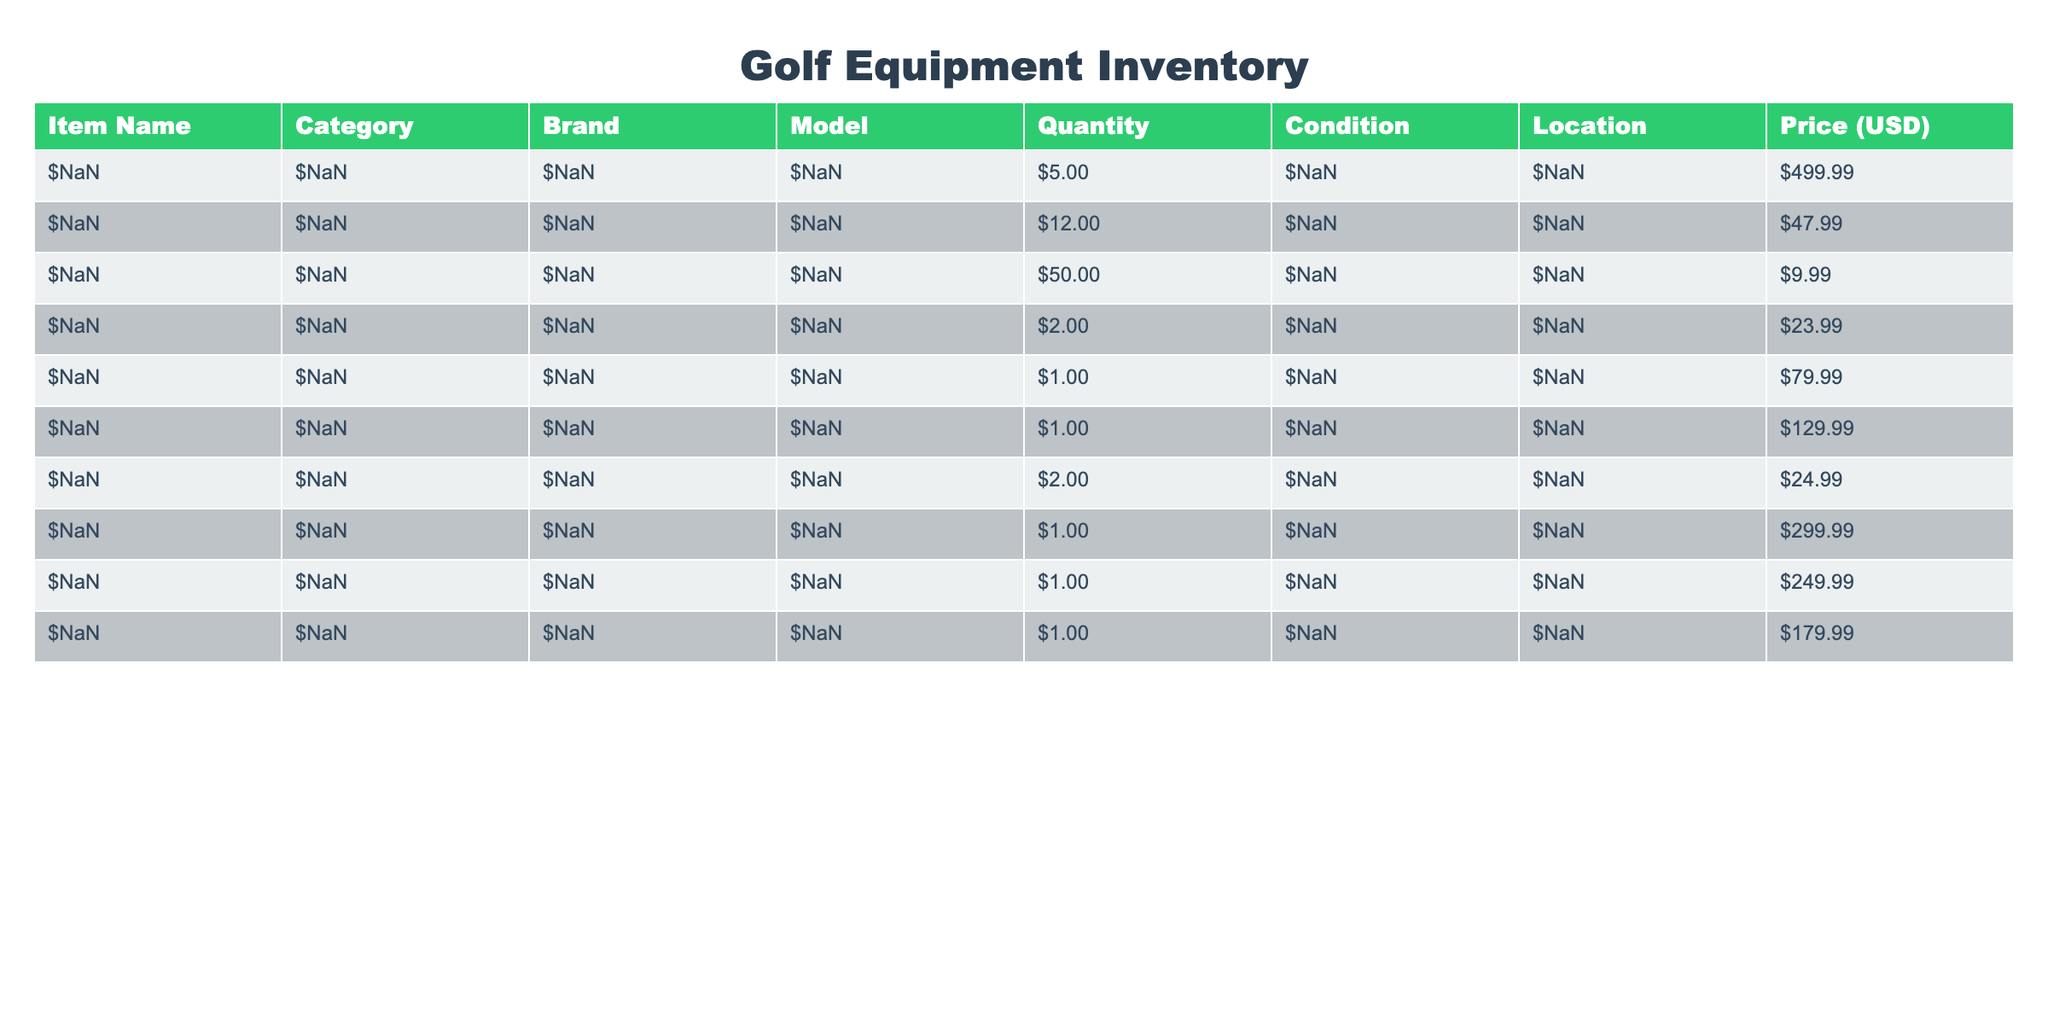What is the total quantity of Golf Balls available? The table states that there are 12 Golf Balls listed under the Quantity column. Thus, the total quantity is simply the number provided.
Answer: 12 What is the price of the Golf Bag? The table indicates that the Golf Bag is priced at 249.99 in the Price (USD) column. Therefore, the answer is taken directly from that column.
Answer: 249.99 Are there more new items than used items in the inventory? In the Condition column, we have 8 new items and 1 used item. Since 8 is greater than 1, the answer is yes.
Answer: Yes What is the total price of all Training Aids? There are two Training Aids listed: Speed Trap priced at 79.99 and Indoor Putting priced at 129.99. The total price is calculated by summing these amounts: 79.99 + 129.99 = 209.98.
Answer: 209.98 How many categories have items listed in the inventory? By analyzing the provided data, we see that the items are categorized into five distinct groups: Clubs, Balls, Accessories, Training Aid, and Bags, making a total of five categories.
Answer: 5 What is the average price of the accessories listed? The total price of Accessories is 9.99 (Golf Tees) + 23.99 (Golf Gloves) + 299.99 (Rangefinder) = 333.97. There are three Accessories, so the average price is 333.97 / 3 = 111.32.
Answer: 111.32 Which item has the highest price in the inventory? The table shows that the Golf Clubs, priced at 499.99, is the item with the highest price compared to others. Thus, this item can be identified directly from the Price column's highest value.
Answer: Golf Clubs Is there a golf training aid in used condition? Upon examining the Condition column, we see that there is one used item, the "Speed Trap" under Training Aids, confirming that there is indeed a golf training aid in used condition.
Answer: Yes What is the total quantity of items in the Pro Shop location? The table lists items in the Pro Shop: Golf Clubs (5), Golf Balls (12), Alignment Sticks (2), Rangefinder (1), Golf Bag (1), and Golf Shoes (1). Summing these gives 5 + 12 + 2 + 1 + 1 + 1 = 22.
Answer: 22 